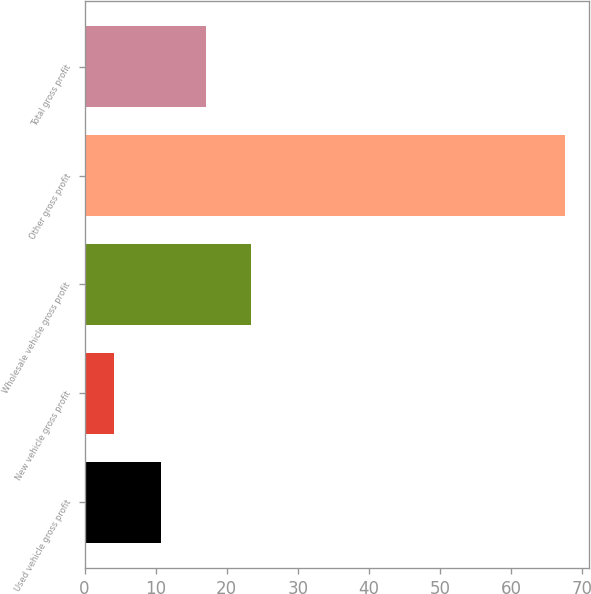Convert chart. <chart><loc_0><loc_0><loc_500><loc_500><bar_chart><fcel>Used vehicle gross profit<fcel>New vehicle gross profit<fcel>Wholesale vehicle gross profit<fcel>Other gross profit<fcel>Total gross profit<nl><fcel>10.8<fcel>4.2<fcel>23.46<fcel>67.5<fcel>17.13<nl></chart> 